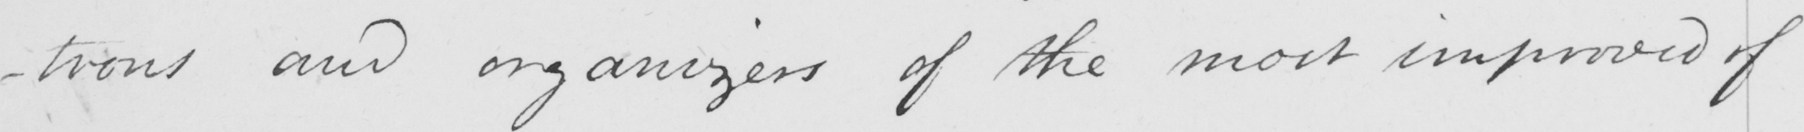Please provide the text content of this handwritten line. -trons and organizers of the most improved of 